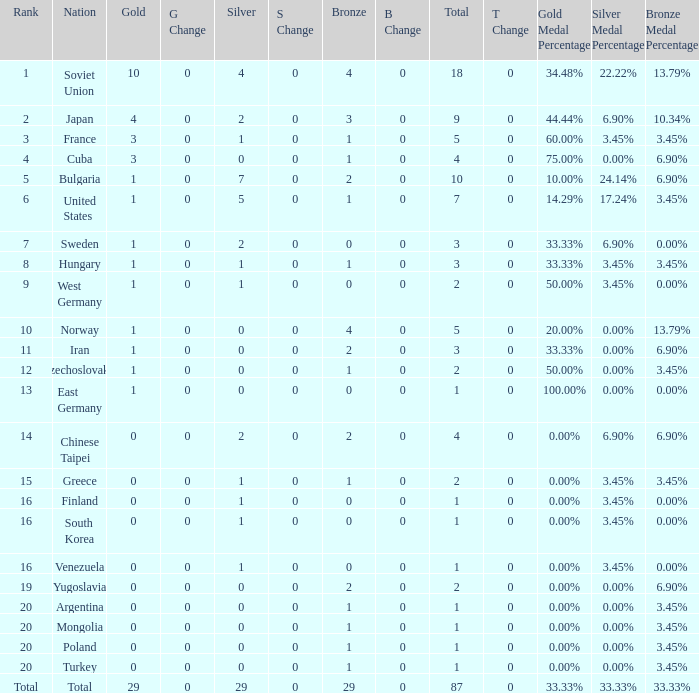What is the sum of gold medals for a rank of 14? 0.0. 